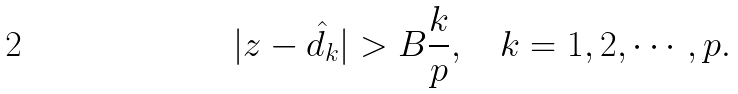Convert formula to latex. <formula><loc_0><loc_0><loc_500><loc_500>| z - \hat { d _ { k } } | > B \frac { k } { p } , \quad k = 1 , 2 , \cdots , p .</formula> 